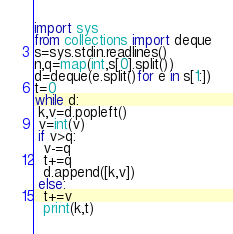Convert code to text. <code><loc_0><loc_0><loc_500><loc_500><_Python_>import sys
from collections import deque
s=sys.stdin.readlines()
n,q=map(int,s[0].split())
d=deque(e.split()for e in s[1:])
t=0
while d:
 k,v=d.popleft()
 v=int(v)
 if v>q:
  v-=q
  t+=q
  d.append([k,v])
 else:
  t+=v
  print(k,t)
</code> 